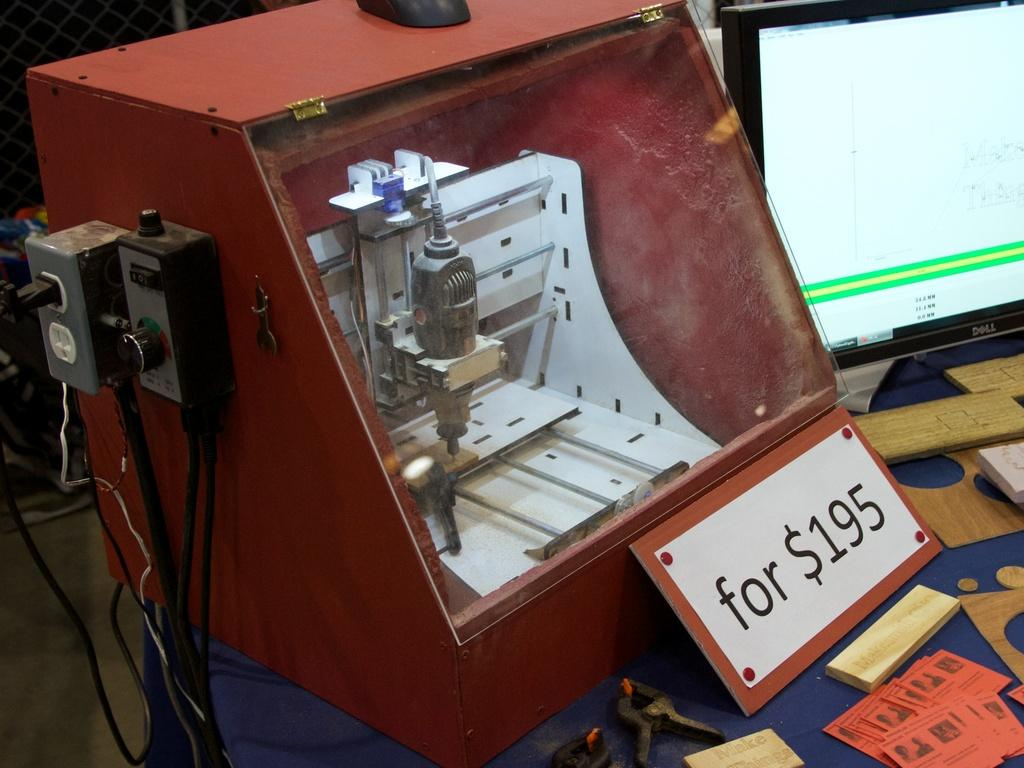<image>
Share a concise interpretation of the image provided. a sign in front of a machine that says 'for $195' 